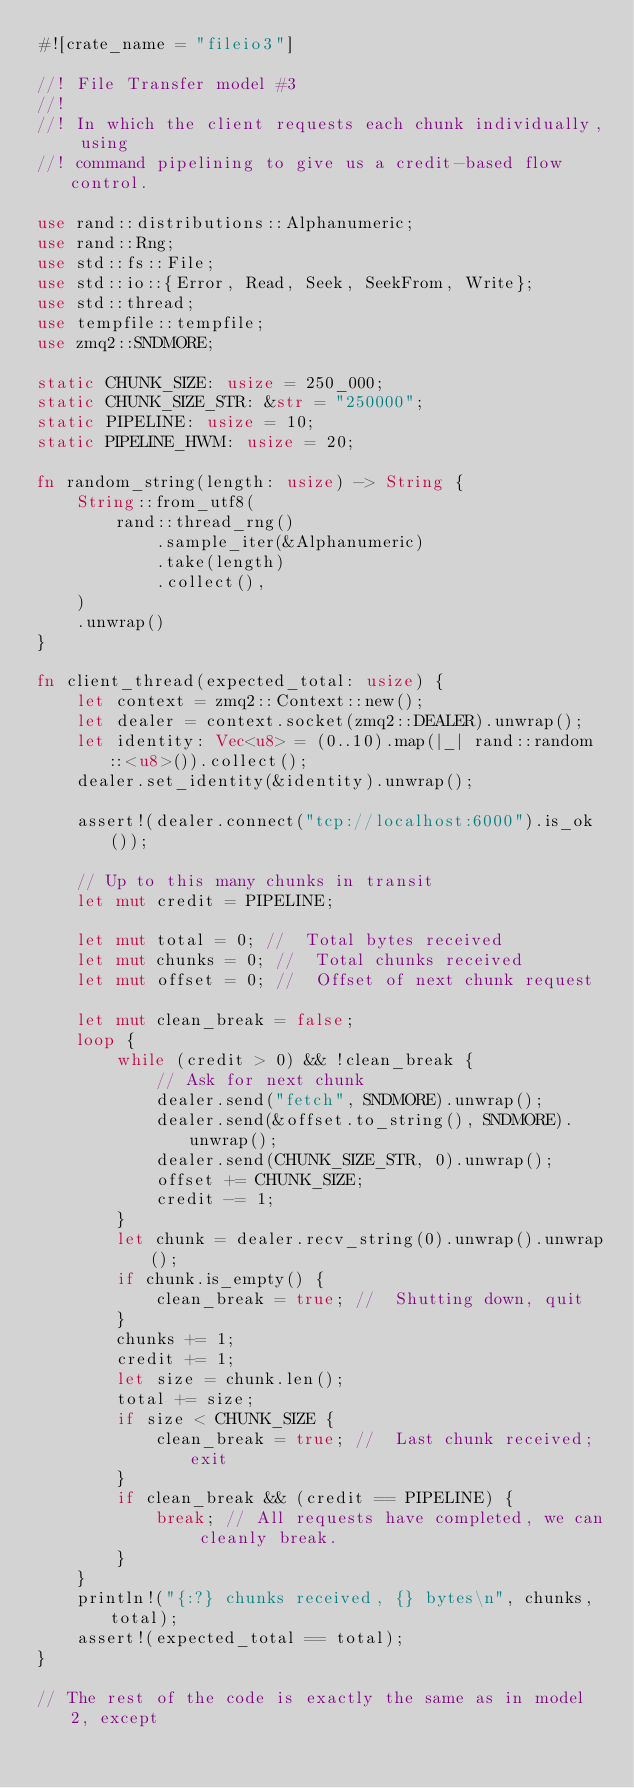Convert code to text. <code><loc_0><loc_0><loc_500><loc_500><_Rust_>#![crate_name = "fileio3"]

//! File Transfer model #3
//!
//! In which the client requests each chunk individually, using
//! command pipelining to give us a credit-based flow control.

use rand::distributions::Alphanumeric;
use rand::Rng;
use std::fs::File;
use std::io::{Error, Read, Seek, SeekFrom, Write};
use std::thread;
use tempfile::tempfile;
use zmq2::SNDMORE;

static CHUNK_SIZE: usize = 250_000;
static CHUNK_SIZE_STR: &str = "250000";
static PIPELINE: usize = 10;
static PIPELINE_HWM: usize = 20;

fn random_string(length: usize) -> String {
    String::from_utf8(
        rand::thread_rng()
            .sample_iter(&Alphanumeric)
            .take(length)
            .collect(),
    )
    .unwrap()
}

fn client_thread(expected_total: usize) {
    let context = zmq2::Context::new();
    let dealer = context.socket(zmq2::DEALER).unwrap();
    let identity: Vec<u8> = (0..10).map(|_| rand::random::<u8>()).collect();
    dealer.set_identity(&identity).unwrap();

    assert!(dealer.connect("tcp://localhost:6000").is_ok());

    // Up to this many chunks in transit
    let mut credit = PIPELINE;

    let mut total = 0; //  Total bytes received
    let mut chunks = 0; //  Total chunks received
    let mut offset = 0; //  Offset of next chunk request

    let mut clean_break = false;
    loop {
        while (credit > 0) && !clean_break {
            // Ask for next chunk
            dealer.send("fetch", SNDMORE).unwrap();
            dealer.send(&offset.to_string(), SNDMORE).unwrap();
            dealer.send(CHUNK_SIZE_STR, 0).unwrap();
            offset += CHUNK_SIZE;
            credit -= 1;
        }
        let chunk = dealer.recv_string(0).unwrap().unwrap();
        if chunk.is_empty() {
            clean_break = true; //  Shutting down, quit
        }
        chunks += 1;
        credit += 1;
        let size = chunk.len();
        total += size;
        if size < CHUNK_SIZE {
            clean_break = true; //  Last chunk received; exit
        }
        if clean_break && (credit == PIPELINE) {
            break; // All requests have completed, we can cleanly break.
        }
    }
    println!("{:?} chunks received, {} bytes\n", chunks, total);
    assert!(expected_total == total);
}

// The rest of the code is exactly the same as in model 2, except</code> 